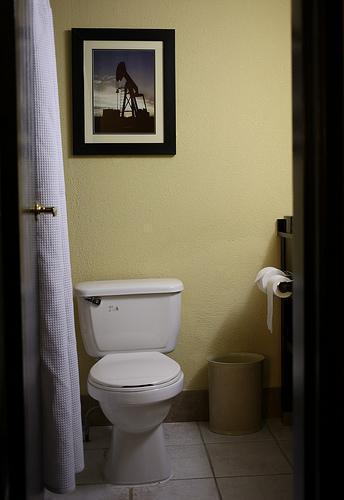How many toilets are there?
Give a very brief answer. 1. How many rolls of toilet paper are there?
Give a very brief answer. 2. 